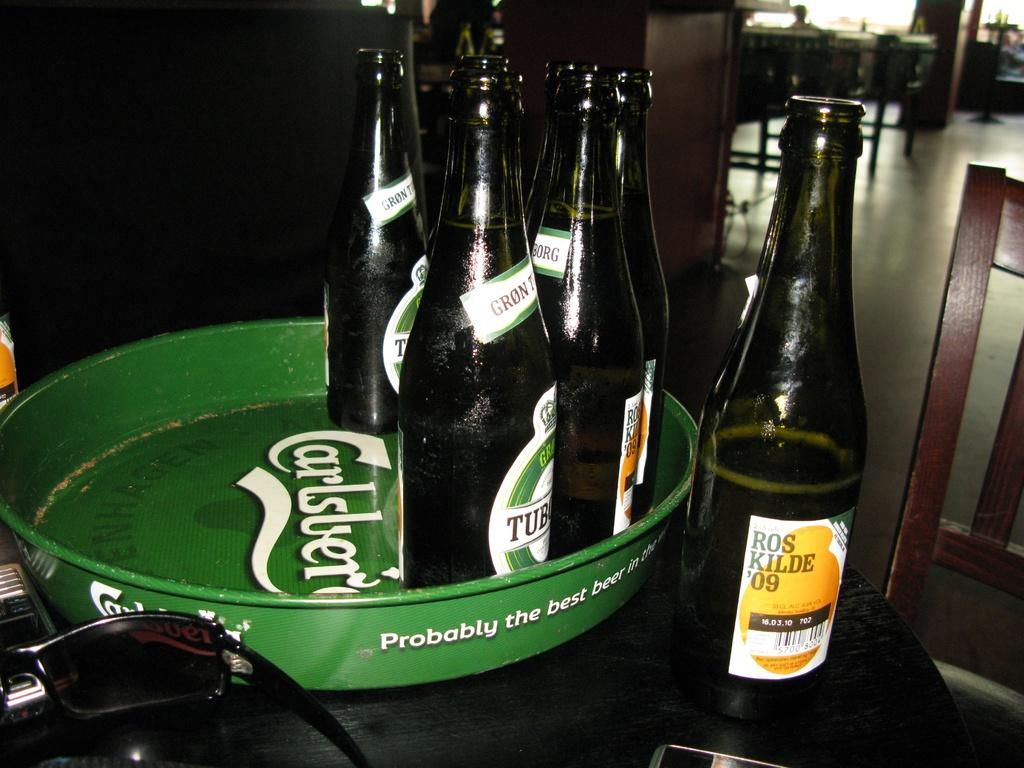<image>
Offer a succinct explanation of the picture presented. 7 bottles of ros kilde '09 are sitting at a bar 